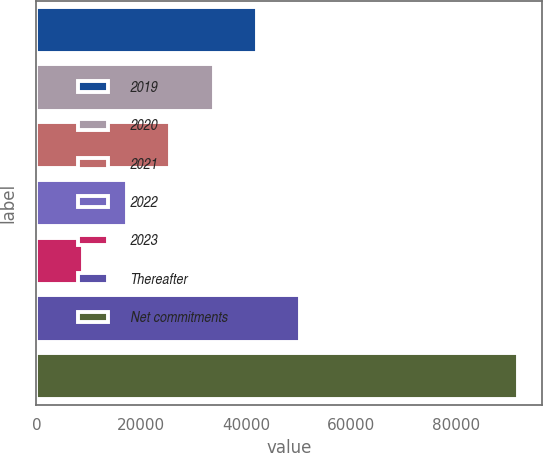<chart> <loc_0><loc_0><loc_500><loc_500><bar_chart><fcel>2019<fcel>2020<fcel>2021<fcel>2022<fcel>2023<fcel>Thereafter<fcel>Net commitments<nl><fcel>42087.8<fcel>33795.6<fcel>25503.4<fcel>17211.2<fcel>8919<fcel>50380<fcel>91841<nl></chart> 